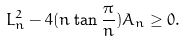Convert formula to latex. <formula><loc_0><loc_0><loc_500><loc_500>L _ { n } ^ { 2 } - 4 ( n \tan { \frac { \pi } { n } } ) A _ { n } \geq 0 .</formula> 